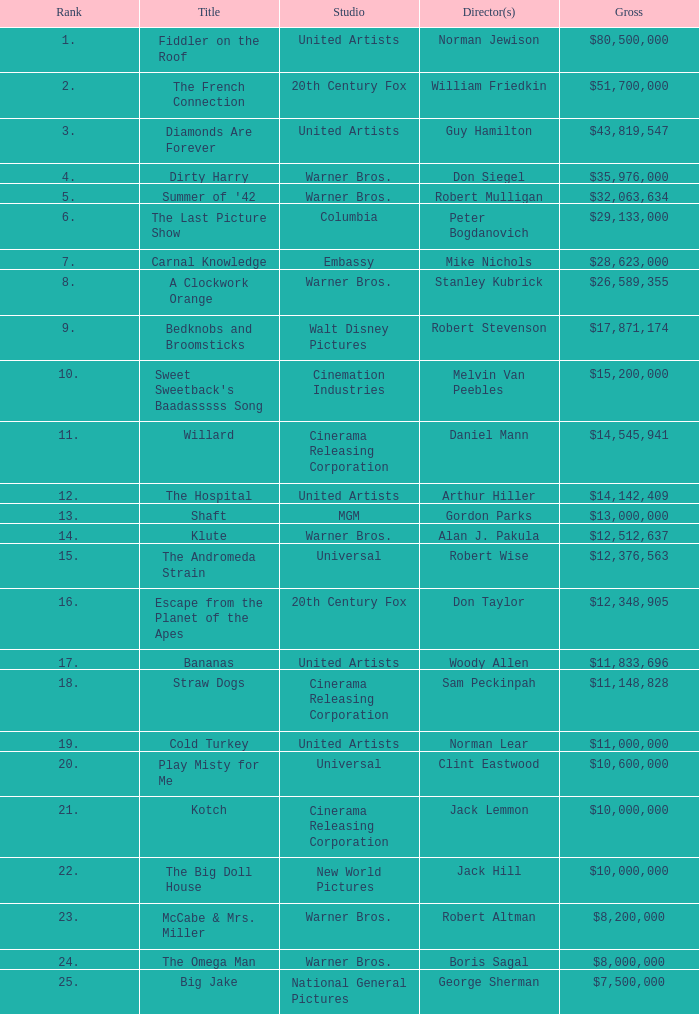What rank has a gross of $35,976,000? 4.0. 